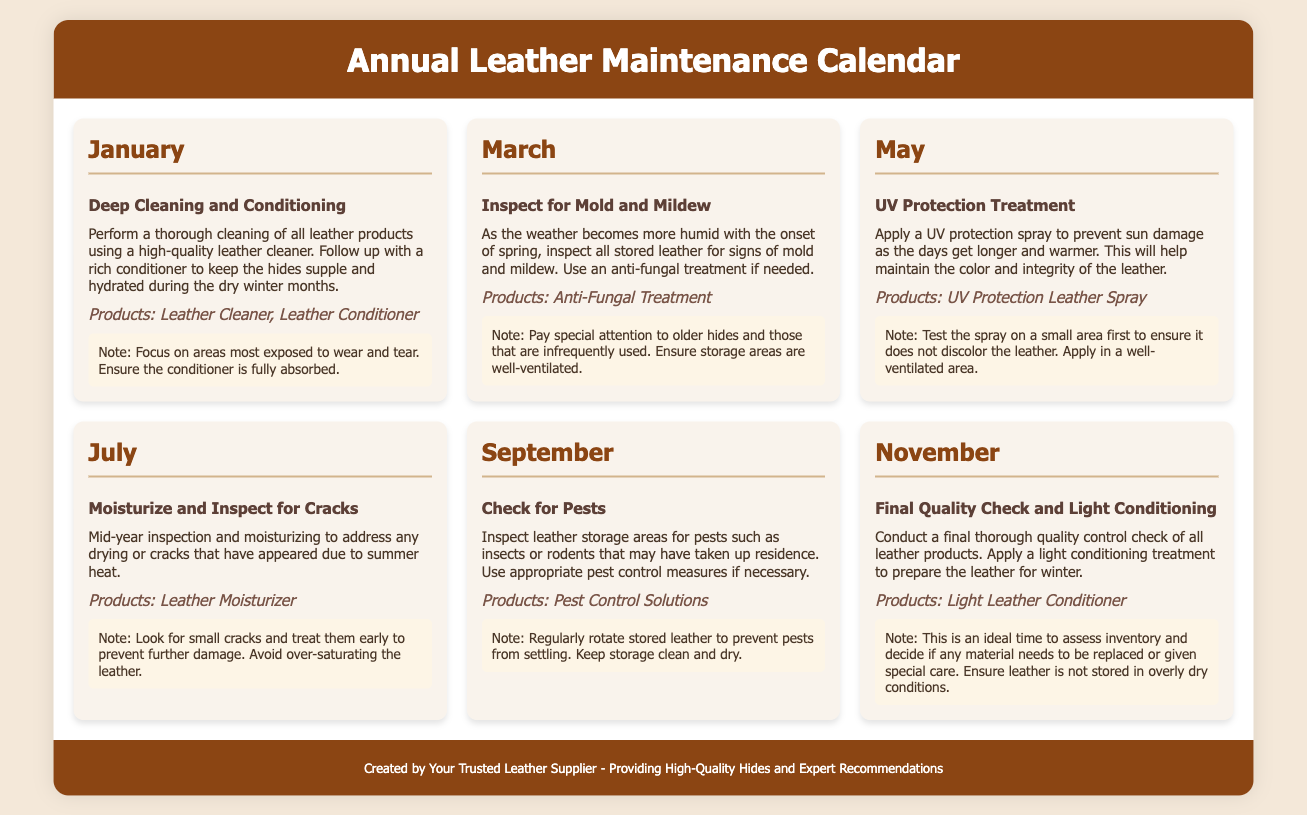What task is scheduled for January? The task scheduled for January is a Deep Cleaning and Conditioning for leather products.
Answer: Deep Cleaning and Conditioning What product is recommended for UV protection treatment? The product recommended for UV protection treatment in May is a UV Protection Leather Spray.
Answer: UV Protection Leather Spray Which month involves checking for pests? The month that involves checking for pests is September.
Answer: September What is the focus in July's maintenance task? The focus in July's maintenance task is to Moisturize and Inspect for Cracks.
Answer: Moisturize and Inspect for Cracks What product should be used in March for mold issues? The product that should be used in March for mold issues is an Anti-Fungal Treatment.
Answer: Anti-Fungal Treatment How many main maintenance tasks are outlined in the calendar? There are six main maintenance tasks outlined in the calendar, one for each specified month.
Answer: Six What is the main action in November's task? The main action in November's task is to conduct a Final Quality Check and Light Conditioning.
Answer: Final Quality Check and Light Conditioning Which month emphasizes on moisturizing due to summer heat? The month that emphasizes on moisturizing due to summer heat is July.
Answer: July What additional precaution is suggested in May regarding the UV protection spray? The additional precaution suggested in May is to test the spray on a small area first.
Answer: Test on a small area first 